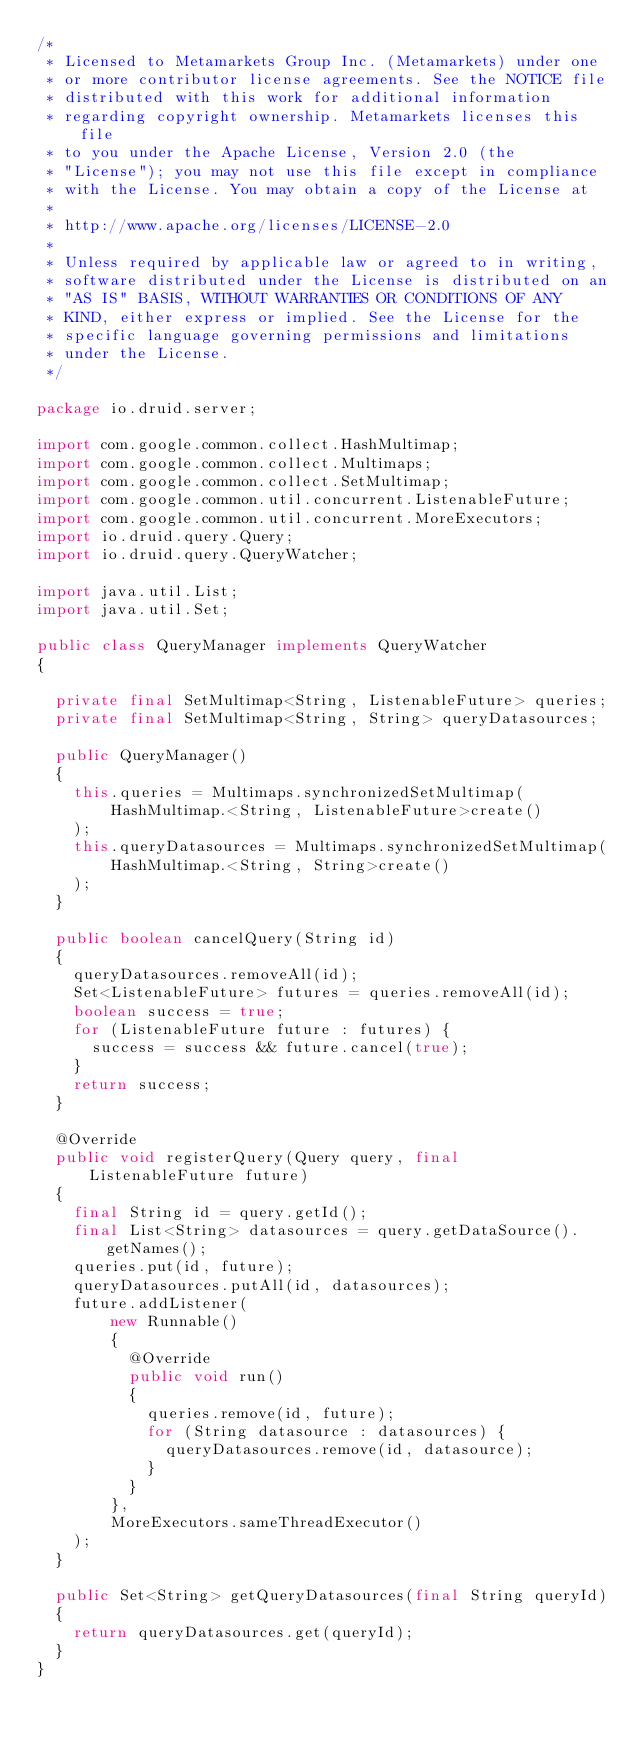<code> <loc_0><loc_0><loc_500><loc_500><_Java_>/*
 * Licensed to Metamarkets Group Inc. (Metamarkets) under one
 * or more contributor license agreements. See the NOTICE file
 * distributed with this work for additional information
 * regarding copyright ownership. Metamarkets licenses this file
 * to you under the Apache License, Version 2.0 (the
 * "License"); you may not use this file except in compliance
 * with the License. You may obtain a copy of the License at
 *
 * http://www.apache.org/licenses/LICENSE-2.0
 *
 * Unless required by applicable law or agreed to in writing,
 * software distributed under the License is distributed on an
 * "AS IS" BASIS, WITHOUT WARRANTIES OR CONDITIONS OF ANY
 * KIND, either express or implied. See the License for the
 * specific language governing permissions and limitations
 * under the License.
 */

package io.druid.server;

import com.google.common.collect.HashMultimap;
import com.google.common.collect.Multimaps;
import com.google.common.collect.SetMultimap;
import com.google.common.util.concurrent.ListenableFuture;
import com.google.common.util.concurrent.MoreExecutors;
import io.druid.query.Query;
import io.druid.query.QueryWatcher;

import java.util.List;
import java.util.Set;

public class QueryManager implements QueryWatcher
{

  private final SetMultimap<String, ListenableFuture> queries;
  private final SetMultimap<String, String> queryDatasources;

  public QueryManager()
  {
    this.queries = Multimaps.synchronizedSetMultimap(
        HashMultimap.<String, ListenableFuture>create()
    );
    this.queryDatasources = Multimaps.synchronizedSetMultimap(
        HashMultimap.<String, String>create()
    );
  }

  public boolean cancelQuery(String id)
  {
    queryDatasources.removeAll(id);
    Set<ListenableFuture> futures = queries.removeAll(id);
    boolean success = true;
    for (ListenableFuture future : futures) {
      success = success && future.cancel(true);
    }
    return success;
  }

  @Override
  public void registerQuery(Query query, final ListenableFuture future)
  {
    final String id = query.getId();
    final List<String> datasources = query.getDataSource().getNames();
    queries.put(id, future);
    queryDatasources.putAll(id, datasources);
    future.addListener(
        new Runnable()
        {
          @Override
          public void run()
          {
            queries.remove(id, future);
            for (String datasource : datasources) {
              queryDatasources.remove(id, datasource);
            }
          }
        },
        MoreExecutors.sameThreadExecutor()
    );
  }

  public Set<String> getQueryDatasources(final String queryId)
  {
    return queryDatasources.get(queryId);
  }
}
</code> 